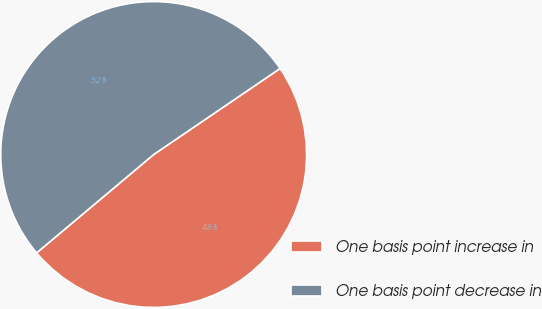Convert chart to OTSL. <chart><loc_0><loc_0><loc_500><loc_500><pie_chart><fcel>One basis point increase in<fcel>One basis point decrease in<nl><fcel>48.39%<fcel>51.61%<nl></chart> 